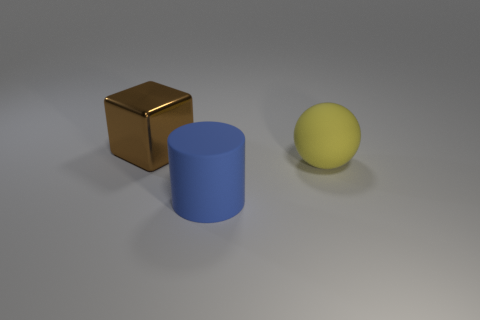There is a big brown object; what number of brown objects are on the left side of it?
Offer a very short reply. 0. What is the color of the big object behind the large matte thing behind the rubber thing in front of the large yellow rubber ball?
Make the answer very short. Brown. Do the rubber object to the left of the big yellow ball and the big object behind the yellow thing have the same color?
Ensure brevity in your answer.  No. There is a large object that is behind the big rubber thing right of the big blue object; what shape is it?
Your answer should be compact. Cube. Is there a red shiny thing of the same size as the blue matte object?
Your answer should be very brief. No. What number of big yellow matte things are the same shape as the large brown object?
Keep it short and to the point. 0. Are there an equal number of big yellow balls on the right side of the blue thing and large brown things that are to the right of the brown thing?
Your answer should be compact. No. Are there any tiny gray things?
Give a very brief answer. No. There is a matte object to the right of the rubber object on the left side of the matte thing that is right of the blue cylinder; how big is it?
Your answer should be compact. Large. There is a shiny thing that is the same size as the blue rubber cylinder; what is its shape?
Offer a very short reply. Cube. 